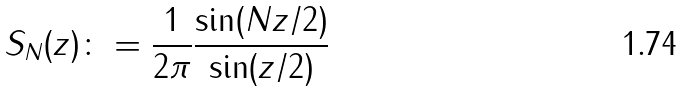Convert formula to latex. <formula><loc_0><loc_0><loc_500><loc_500>S _ { N } ( z ) \colon = \frac { 1 } { 2 \pi } \frac { \sin ( N z / 2 ) } { \sin ( z / 2 ) }</formula> 